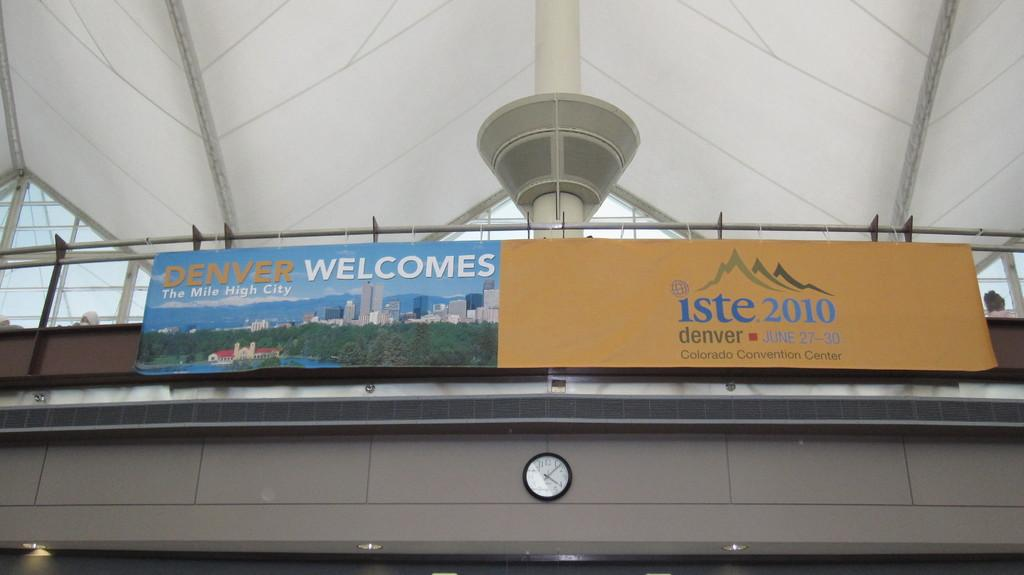<image>
Present a compact description of the photo's key features. Two banners, each welcoming guests to the Denver Convention Center, adorn a balcony 